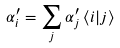<formula> <loc_0><loc_0><loc_500><loc_500>\alpha ^ { \prime } _ { i } = \sum _ { j } \alpha _ { j } ^ { \prime } \, \langle i | j \rangle</formula> 